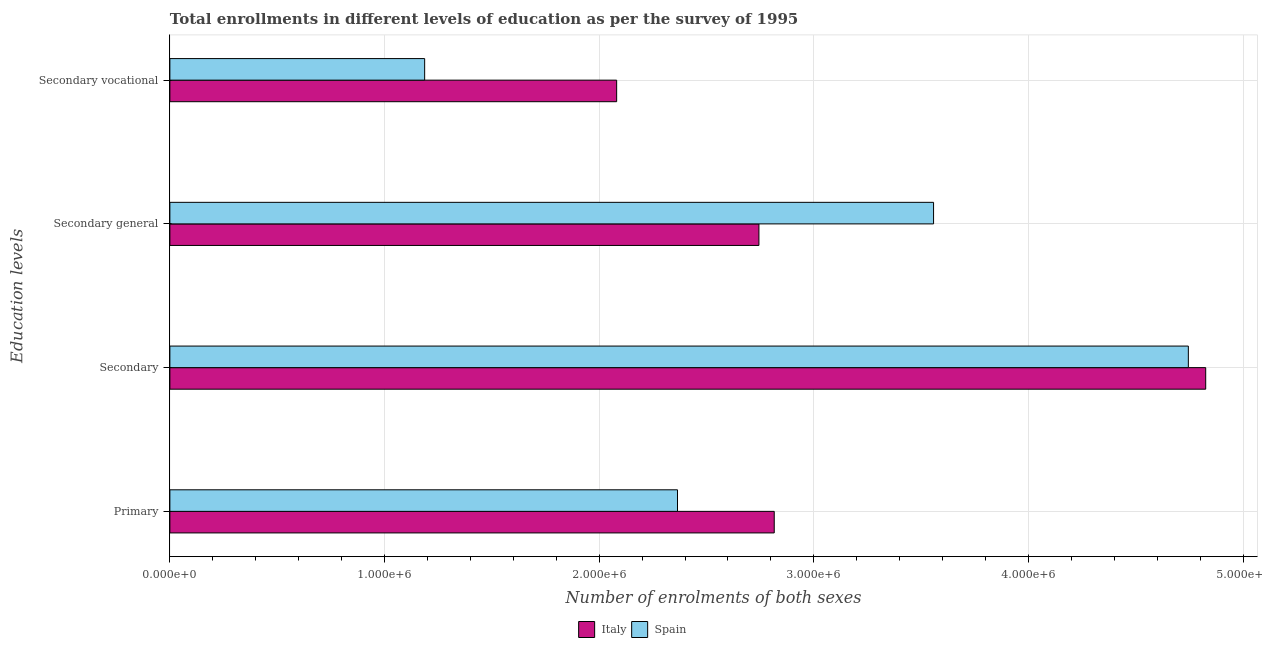How many bars are there on the 3rd tick from the top?
Give a very brief answer. 2. What is the label of the 2nd group of bars from the top?
Offer a terse response. Secondary general. What is the number of enrolments in secondary general education in Spain?
Make the answer very short. 3.56e+06. Across all countries, what is the maximum number of enrolments in secondary vocational education?
Give a very brief answer. 2.08e+06. Across all countries, what is the minimum number of enrolments in secondary education?
Offer a terse response. 4.74e+06. In which country was the number of enrolments in primary education maximum?
Your answer should be compact. Italy. What is the total number of enrolments in secondary education in the graph?
Keep it short and to the point. 9.57e+06. What is the difference between the number of enrolments in secondary vocational education in Italy and that in Spain?
Offer a very short reply. 8.94e+05. What is the difference between the number of enrolments in secondary vocational education in Spain and the number of enrolments in primary education in Italy?
Offer a very short reply. -1.63e+06. What is the average number of enrolments in secondary education per country?
Ensure brevity in your answer.  4.79e+06. What is the difference between the number of enrolments in primary education and number of enrolments in secondary education in Spain?
Your response must be concise. -2.38e+06. What is the ratio of the number of enrolments in secondary vocational education in Spain to that in Italy?
Your response must be concise. 0.57. Is the number of enrolments in secondary education in Italy less than that in Spain?
Keep it short and to the point. No. Is the difference between the number of enrolments in secondary general education in Italy and Spain greater than the difference between the number of enrolments in secondary education in Italy and Spain?
Give a very brief answer. No. What is the difference between the highest and the second highest number of enrolments in primary education?
Make the answer very short. 4.51e+05. What is the difference between the highest and the lowest number of enrolments in secondary general education?
Provide a short and direct response. 8.14e+05. Is the sum of the number of enrolments in secondary education in Italy and Spain greater than the maximum number of enrolments in secondary general education across all countries?
Your response must be concise. Yes. What does the 1st bar from the top in Secondary represents?
Offer a very short reply. Spain. What does the 1st bar from the bottom in Primary represents?
Provide a succinct answer. Italy. Is it the case that in every country, the sum of the number of enrolments in primary education and number of enrolments in secondary education is greater than the number of enrolments in secondary general education?
Make the answer very short. Yes. How many bars are there?
Give a very brief answer. 8. Are all the bars in the graph horizontal?
Provide a succinct answer. Yes. How many countries are there in the graph?
Give a very brief answer. 2. What is the difference between two consecutive major ticks on the X-axis?
Your response must be concise. 1.00e+06. Are the values on the major ticks of X-axis written in scientific E-notation?
Your answer should be compact. Yes. How many legend labels are there?
Offer a very short reply. 2. How are the legend labels stacked?
Give a very brief answer. Horizontal. What is the title of the graph?
Offer a terse response. Total enrollments in different levels of education as per the survey of 1995. Does "Central Europe" appear as one of the legend labels in the graph?
Provide a short and direct response. No. What is the label or title of the X-axis?
Your answer should be compact. Number of enrolments of both sexes. What is the label or title of the Y-axis?
Give a very brief answer. Education levels. What is the Number of enrolments of both sexes in Italy in Primary?
Offer a terse response. 2.82e+06. What is the Number of enrolments of both sexes in Spain in Primary?
Offer a very short reply. 2.36e+06. What is the Number of enrolments of both sexes of Italy in Secondary?
Your response must be concise. 4.83e+06. What is the Number of enrolments of both sexes in Spain in Secondary?
Ensure brevity in your answer.  4.74e+06. What is the Number of enrolments of both sexes of Italy in Secondary general?
Offer a terse response. 2.74e+06. What is the Number of enrolments of both sexes in Spain in Secondary general?
Your answer should be compact. 3.56e+06. What is the Number of enrolments of both sexes in Italy in Secondary vocational?
Give a very brief answer. 2.08e+06. What is the Number of enrolments of both sexes in Spain in Secondary vocational?
Offer a very short reply. 1.19e+06. Across all Education levels, what is the maximum Number of enrolments of both sexes in Italy?
Make the answer very short. 4.83e+06. Across all Education levels, what is the maximum Number of enrolments of both sexes of Spain?
Give a very brief answer. 4.74e+06. Across all Education levels, what is the minimum Number of enrolments of both sexes in Italy?
Offer a very short reply. 2.08e+06. Across all Education levels, what is the minimum Number of enrolments of both sexes of Spain?
Offer a very short reply. 1.19e+06. What is the total Number of enrolments of both sexes in Italy in the graph?
Offer a very short reply. 1.25e+07. What is the total Number of enrolments of both sexes of Spain in the graph?
Ensure brevity in your answer.  1.19e+07. What is the difference between the Number of enrolments of both sexes in Italy in Primary and that in Secondary?
Your answer should be compact. -2.01e+06. What is the difference between the Number of enrolments of both sexes of Spain in Primary and that in Secondary?
Offer a terse response. -2.38e+06. What is the difference between the Number of enrolments of both sexes in Italy in Primary and that in Secondary general?
Your response must be concise. 7.14e+04. What is the difference between the Number of enrolments of both sexes in Spain in Primary and that in Secondary general?
Your answer should be compact. -1.19e+06. What is the difference between the Number of enrolments of both sexes in Italy in Primary and that in Secondary vocational?
Keep it short and to the point. 7.34e+05. What is the difference between the Number of enrolments of both sexes of Spain in Primary and that in Secondary vocational?
Ensure brevity in your answer.  1.18e+06. What is the difference between the Number of enrolments of both sexes in Italy in Secondary and that in Secondary general?
Your answer should be compact. 2.08e+06. What is the difference between the Number of enrolments of both sexes of Spain in Secondary and that in Secondary general?
Keep it short and to the point. 1.19e+06. What is the difference between the Number of enrolments of both sexes of Italy in Secondary and that in Secondary vocational?
Keep it short and to the point. 2.74e+06. What is the difference between the Number of enrolments of both sexes of Spain in Secondary and that in Secondary vocational?
Offer a very short reply. 3.56e+06. What is the difference between the Number of enrolments of both sexes in Italy in Secondary general and that in Secondary vocational?
Your answer should be very brief. 6.63e+05. What is the difference between the Number of enrolments of both sexes of Spain in Secondary general and that in Secondary vocational?
Your answer should be very brief. 2.37e+06. What is the difference between the Number of enrolments of both sexes in Italy in Primary and the Number of enrolments of both sexes in Spain in Secondary?
Give a very brief answer. -1.93e+06. What is the difference between the Number of enrolments of both sexes in Italy in Primary and the Number of enrolments of both sexes in Spain in Secondary general?
Keep it short and to the point. -7.42e+05. What is the difference between the Number of enrolments of both sexes of Italy in Primary and the Number of enrolments of both sexes of Spain in Secondary vocational?
Provide a short and direct response. 1.63e+06. What is the difference between the Number of enrolments of both sexes of Italy in Secondary and the Number of enrolments of both sexes of Spain in Secondary general?
Keep it short and to the point. 1.27e+06. What is the difference between the Number of enrolments of both sexes of Italy in Secondary and the Number of enrolments of both sexes of Spain in Secondary vocational?
Ensure brevity in your answer.  3.64e+06. What is the difference between the Number of enrolments of both sexes of Italy in Secondary general and the Number of enrolments of both sexes of Spain in Secondary vocational?
Give a very brief answer. 1.56e+06. What is the average Number of enrolments of both sexes in Italy per Education levels?
Offer a very short reply. 3.12e+06. What is the average Number of enrolments of both sexes in Spain per Education levels?
Keep it short and to the point. 2.96e+06. What is the difference between the Number of enrolments of both sexes of Italy and Number of enrolments of both sexes of Spain in Primary?
Keep it short and to the point. 4.51e+05. What is the difference between the Number of enrolments of both sexes of Italy and Number of enrolments of both sexes of Spain in Secondary?
Keep it short and to the point. 8.09e+04. What is the difference between the Number of enrolments of both sexes of Italy and Number of enrolments of both sexes of Spain in Secondary general?
Make the answer very short. -8.14e+05. What is the difference between the Number of enrolments of both sexes in Italy and Number of enrolments of both sexes in Spain in Secondary vocational?
Your answer should be very brief. 8.94e+05. What is the ratio of the Number of enrolments of both sexes of Italy in Primary to that in Secondary?
Your response must be concise. 0.58. What is the ratio of the Number of enrolments of both sexes in Spain in Primary to that in Secondary?
Ensure brevity in your answer.  0.5. What is the ratio of the Number of enrolments of both sexes of Italy in Primary to that in Secondary general?
Your answer should be very brief. 1.03. What is the ratio of the Number of enrolments of both sexes of Spain in Primary to that in Secondary general?
Your response must be concise. 0.66. What is the ratio of the Number of enrolments of both sexes of Italy in Primary to that in Secondary vocational?
Ensure brevity in your answer.  1.35. What is the ratio of the Number of enrolments of both sexes of Spain in Primary to that in Secondary vocational?
Ensure brevity in your answer.  1.99. What is the ratio of the Number of enrolments of both sexes in Italy in Secondary to that in Secondary general?
Make the answer very short. 1.76. What is the ratio of the Number of enrolments of both sexes of Spain in Secondary to that in Secondary general?
Ensure brevity in your answer.  1.33. What is the ratio of the Number of enrolments of both sexes in Italy in Secondary to that in Secondary vocational?
Provide a short and direct response. 2.32. What is the ratio of the Number of enrolments of both sexes in Spain in Secondary to that in Secondary vocational?
Provide a succinct answer. 4. What is the ratio of the Number of enrolments of both sexes in Italy in Secondary general to that in Secondary vocational?
Provide a short and direct response. 1.32. What is the ratio of the Number of enrolments of both sexes in Spain in Secondary general to that in Secondary vocational?
Offer a very short reply. 3. What is the difference between the highest and the second highest Number of enrolments of both sexes of Italy?
Ensure brevity in your answer.  2.01e+06. What is the difference between the highest and the second highest Number of enrolments of both sexes of Spain?
Make the answer very short. 1.19e+06. What is the difference between the highest and the lowest Number of enrolments of both sexes of Italy?
Give a very brief answer. 2.74e+06. What is the difference between the highest and the lowest Number of enrolments of both sexes in Spain?
Your answer should be compact. 3.56e+06. 